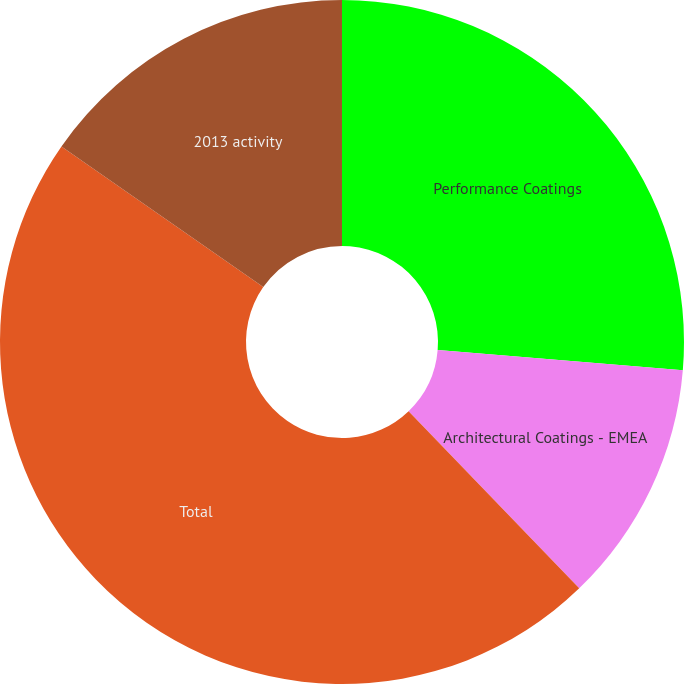Convert chart. <chart><loc_0><loc_0><loc_500><loc_500><pie_chart><fcel>Performance Coatings<fcel>Architectural Coatings - EMEA<fcel>Total<fcel>2013 activity<nl><fcel>26.32%<fcel>11.48%<fcel>46.89%<fcel>15.31%<nl></chart> 